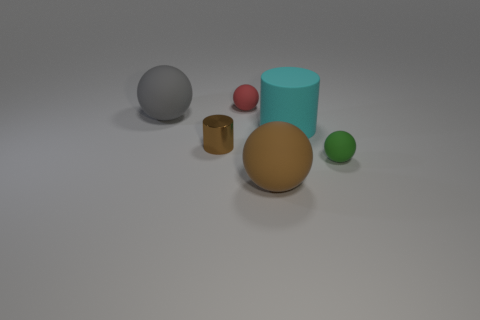There is a gray thing; is its size the same as the cyan thing that is left of the green ball?
Provide a succinct answer. Yes. How many red things are either blocks or tiny rubber balls?
Keep it short and to the point. 1. What number of green spheres are there?
Keep it short and to the point. 1. How big is the rubber sphere left of the brown cylinder?
Make the answer very short. Large. Is the size of the cyan matte thing the same as the gray thing?
Your answer should be very brief. Yes. How many things are either brown cylinders or big things that are in front of the brown cylinder?
Your answer should be compact. 2. What material is the red sphere?
Provide a succinct answer. Rubber. Is there anything else that is the same color as the tiny shiny cylinder?
Provide a succinct answer. Yes. Do the gray matte object and the green matte object have the same shape?
Ensure brevity in your answer.  Yes. What is the size of the rubber ball that is to the left of the small sphere on the left side of the matte thing right of the big cyan matte thing?
Make the answer very short. Large. 